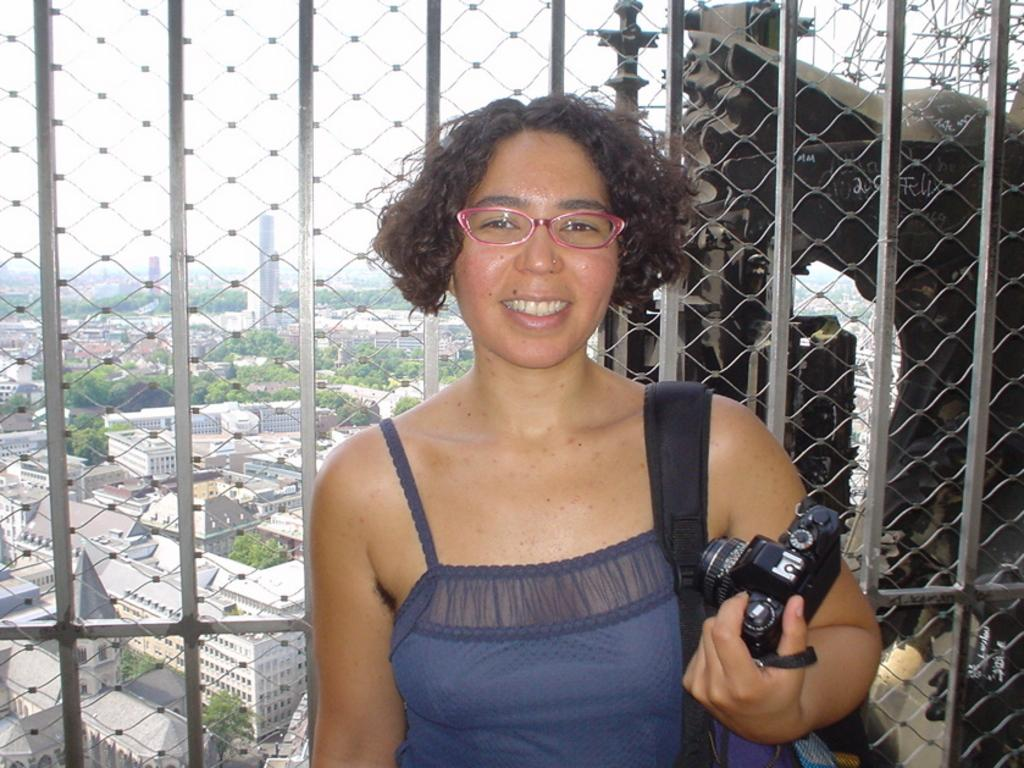What can be seen in the sky in the image? The sky is visible in the image. What type of natural elements are present in the image? There are trees in the image. What type of man-made structures can be seen in the image? There are buildings in the image. What type of barrier is present in the image? There is a fencing in the image. Who is present in the image? There is a woman standing in the image. What is the woman holding in the image? The woman is holding a camera. What accessory is the woman wearing in the image? The woman is wearing a bag. What color is the ink used by the woman in the image? There is no ink present in the image, as the woman is holding a camera, not a pen or writing instrument. 